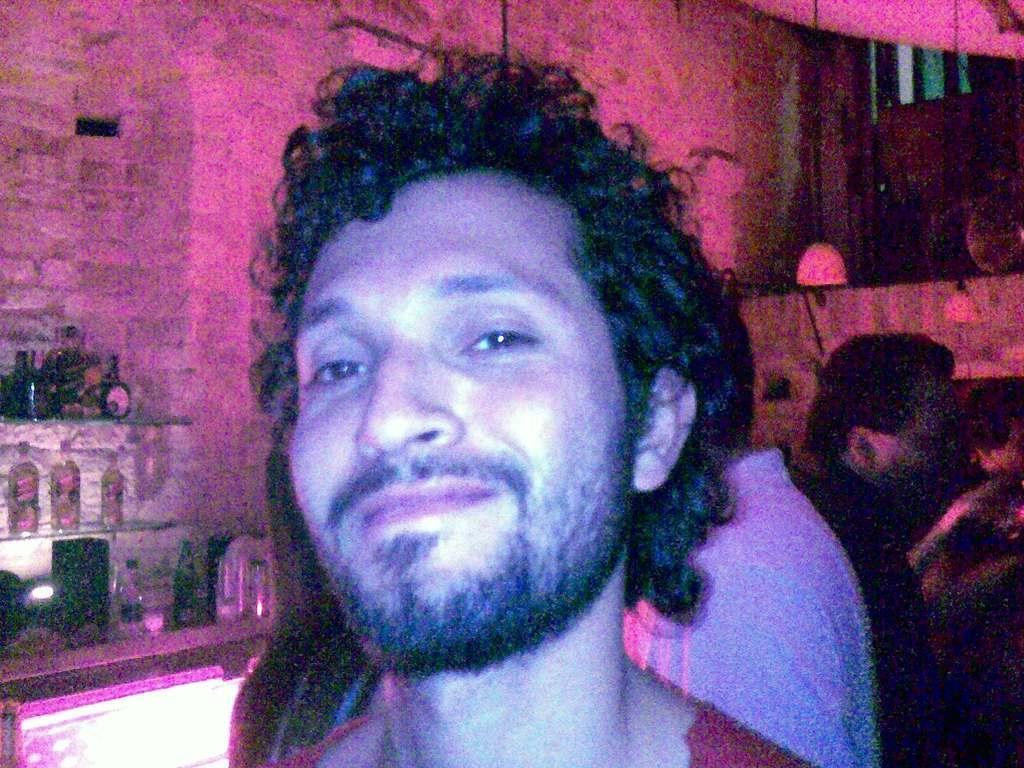What is the main subject of the image? The main subject of the image is a group of people. Can you describe any objects or features in the background? Yes, there are bottles in the racks on the left side of the image. What type of stamp can be seen on the forehead of one of the people in the image? There is no stamp visible on anyone's forehead in the image. 